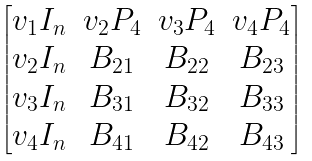Convert formula to latex. <formula><loc_0><loc_0><loc_500><loc_500>\begin{bmatrix} v _ { 1 } I _ { n } & v _ { 2 } P _ { 4 } & v _ { 3 } P _ { 4 } & v _ { 4 } P _ { 4 } \\ v _ { 2 } I _ { n } & B _ { 2 1 } & B _ { 2 2 } & B _ { 2 3 } \\ v _ { 3 } I _ { n } & B _ { 3 1 } & B _ { 3 2 } & B _ { 3 3 } \\ v _ { 4 } I _ { n } & B _ { 4 1 } & B _ { 4 2 } & B _ { 4 3 } \end{bmatrix}</formula> 